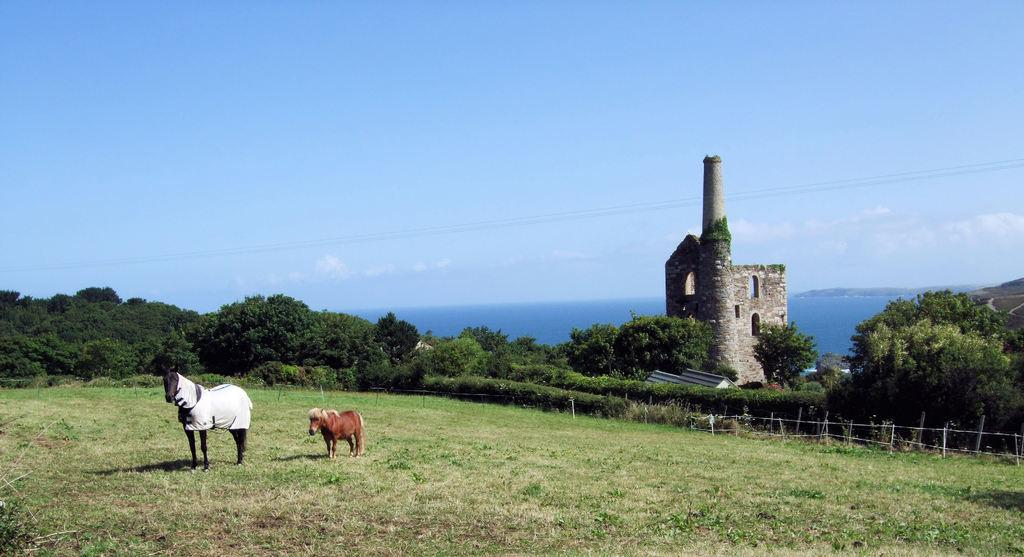How many horses are in the image? There are two horses in the image. What is the position of the horses in the image? The horses are standing on the ground. What type of surface is the horses standing on? The ground is covered with grass. What can be seen in the background of the image? There are trees and a building visible in the background of the image. What type of yam is being used to measure the distance between the two horses in the image? There is no yam present in the image, and the horses' distance is not being measured. 